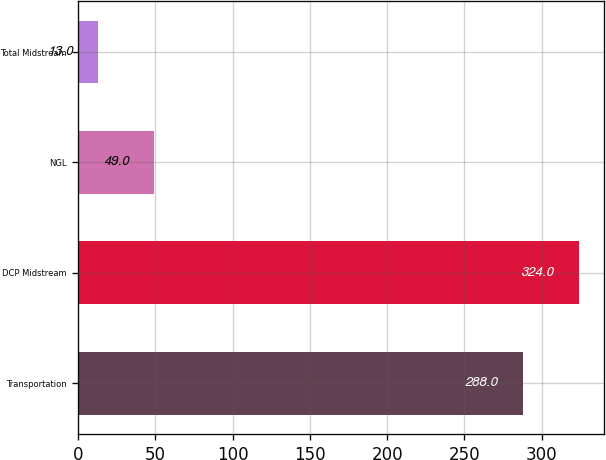<chart> <loc_0><loc_0><loc_500><loc_500><bar_chart><fcel>Transportation<fcel>DCP Midstream<fcel>NGL<fcel>Total Midstream<nl><fcel>288<fcel>324<fcel>49<fcel>13<nl></chart> 